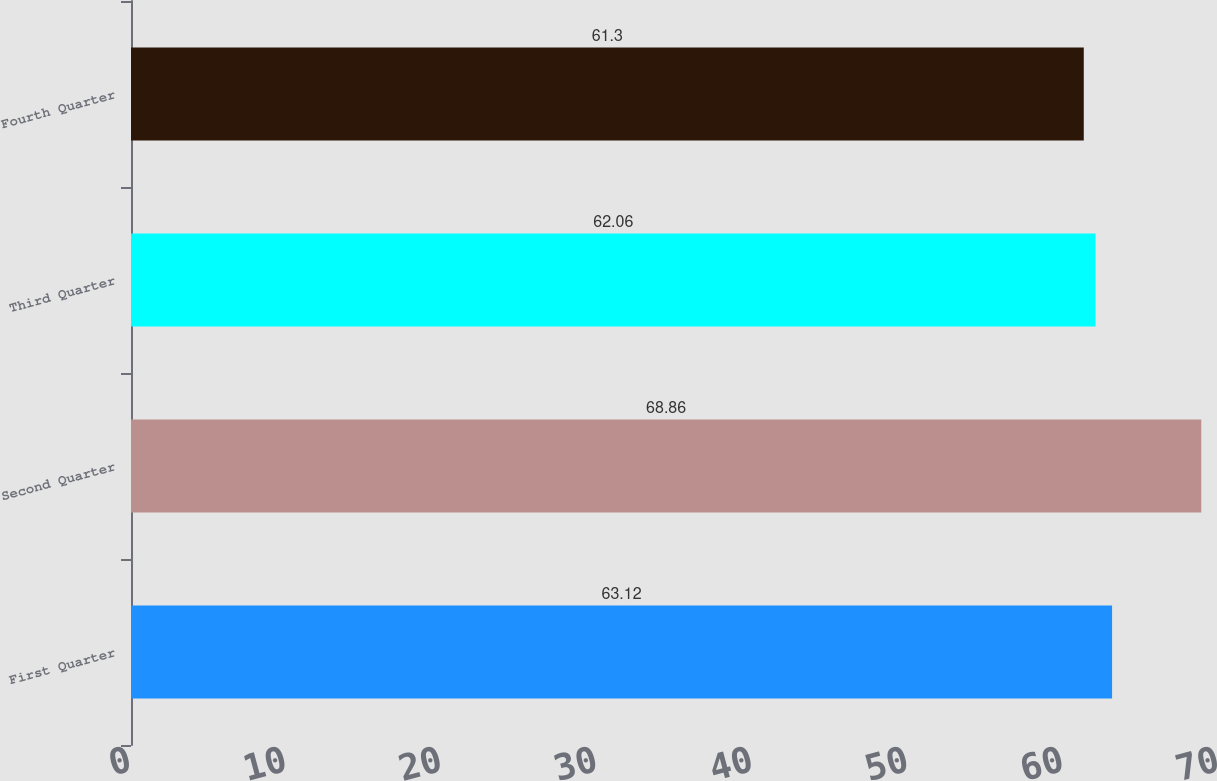<chart> <loc_0><loc_0><loc_500><loc_500><bar_chart><fcel>First Quarter<fcel>Second Quarter<fcel>Third Quarter<fcel>Fourth Quarter<nl><fcel>63.12<fcel>68.86<fcel>62.06<fcel>61.3<nl></chart> 